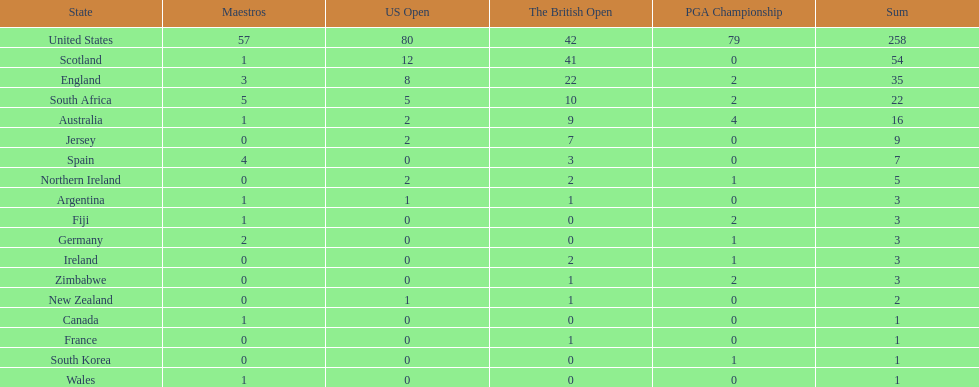Which african country has the least champion golfers according to this table? Zimbabwe. 